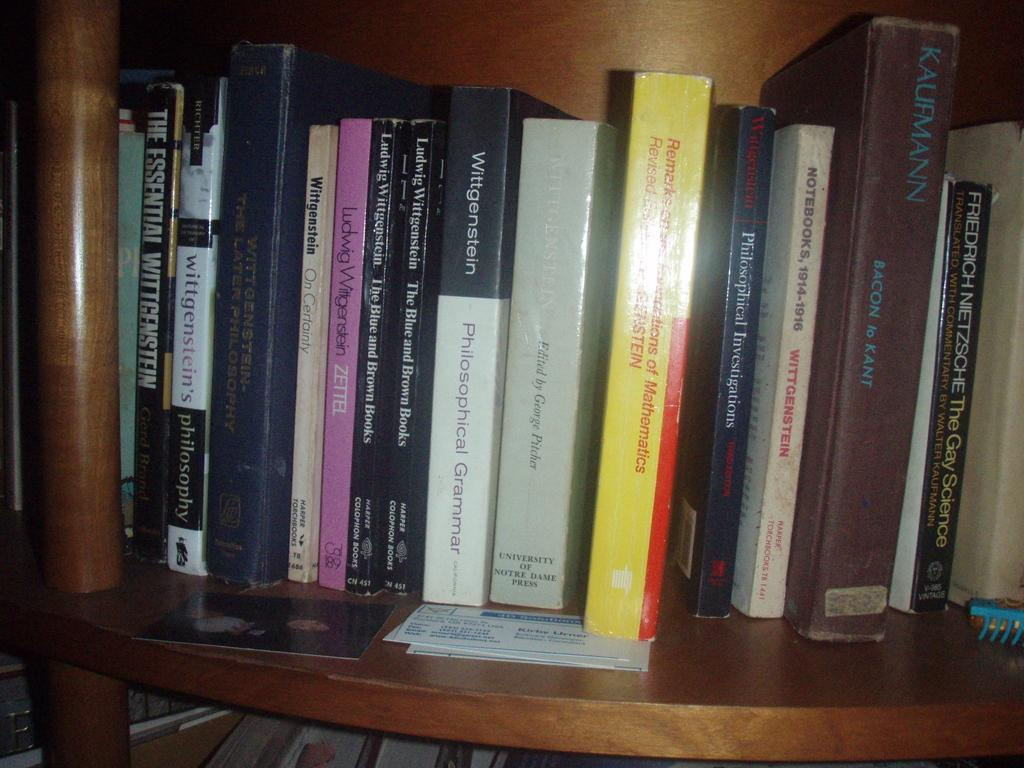<image>
Render a clear and concise summary of the photo. Several philosophy books sit together on a shelf. 